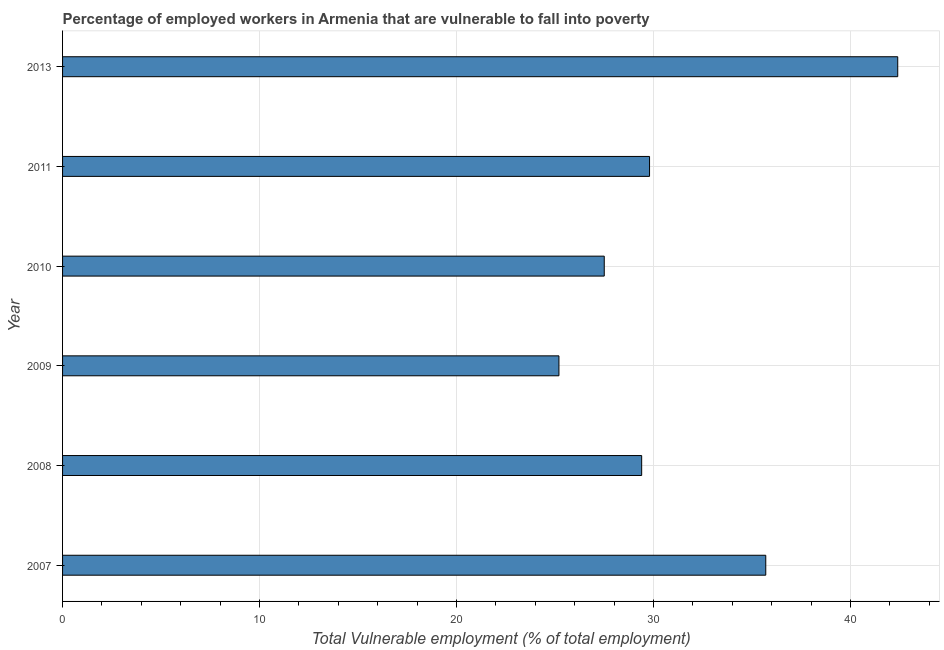What is the title of the graph?
Your answer should be compact. Percentage of employed workers in Armenia that are vulnerable to fall into poverty. What is the label or title of the X-axis?
Offer a very short reply. Total Vulnerable employment (% of total employment). What is the label or title of the Y-axis?
Ensure brevity in your answer.  Year. What is the total vulnerable employment in 2013?
Your answer should be compact. 42.4. Across all years, what is the maximum total vulnerable employment?
Your answer should be compact. 42.4. Across all years, what is the minimum total vulnerable employment?
Make the answer very short. 25.2. In which year was the total vulnerable employment maximum?
Offer a very short reply. 2013. What is the sum of the total vulnerable employment?
Offer a very short reply. 190. What is the difference between the total vulnerable employment in 2007 and 2008?
Your response must be concise. 6.3. What is the average total vulnerable employment per year?
Make the answer very short. 31.67. What is the median total vulnerable employment?
Offer a terse response. 29.6. Do a majority of the years between 2008 and 2010 (inclusive) have total vulnerable employment greater than 22 %?
Your answer should be compact. Yes. What is the ratio of the total vulnerable employment in 2007 to that in 2009?
Offer a terse response. 1.42. Is the total vulnerable employment in 2007 less than that in 2008?
Provide a succinct answer. No. Is the sum of the total vulnerable employment in 2010 and 2011 greater than the maximum total vulnerable employment across all years?
Offer a very short reply. Yes. In how many years, is the total vulnerable employment greater than the average total vulnerable employment taken over all years?
Provide a short and direct response. 2. How many bars are there?
Your answer should be very brief. 6. Are the values on the major ticks of X-axis written in scientific E-notation?
Give a very brief answer. No. What is the Total Vulnerable employment (% of total employment) in 2007?
Give a very brief answer. 35.7. What is the Total Vulnerable employment (% of total employment) in 2008?
Offer a terse response. 29.4. What is the Total Vulnerable employment (% of total employment) of 2009?
Offer a terse response. 25.2. What is the Total Vulnerable employment (% of total employment) in 2011?
Make the answer very short. 29.8. What is the Total Vulnerable employment (% of total employment) in 2013?
Give a very brief answer. 42.4. What is the difference between the Total Vulnerable employment (% of total employment) in 2007 and 2009?
Make the answer very short. 10.5. What is the difference between the Total Vulnerable employment (% of total employment) in 2007 and 2010?
Your response must be concise. 8.2. What is the difference between the Total Vulnerable employment (% of total employment) in 2007 and 2011?
Your answer should be very brief. 5.9. What is the difference between the Total Vulnerable employment (% of total employment) in 2007 and 2013?
Keep it short and to the point. -6.7. What is the difference between the Total Vulnerable employment (% of total employment) in 2008 and 2009?
Make the answer very short. 4.2. What is the difference between the Total Vulnerable employment (% of total employment) in 2008 and 2010?
Make the answer very short. 1.9. What is the difference between the Total Vulnerable employment (% of total employment) in 2008 and 2011?
Your response must be concise. -0.4. What is the difference between the Total Vulnerable employment (% of total employment) in 2009 and 2013?
Ensure brevity in your answer.  -17.2. What is the difference between the Total Vulnerable employment (% of total employment) in 2010 and 2013?
Ensure brevity in your answer.  -14.9. What is the difference between the Total Vulnerable employment (% of total employment) in 2011 and 2013?
Provide a succinct answer. -12.6. What is the ratio of the Total Vulnerable employment (% of total employment) in 2007 to that in 2008?
Provide a short and direct response. 1.21. What is the ratio of the Total Vulnerable employment (% of total employment) in 2007 to that in 2009?
Make the answer very short. 1.42. What is the ratio of the Total Vulnerable employment (% of total employment) in 2007 to that in 2010?
Provide a short and direct response. 1.3. What is the ratio of the Total Vulnerable employment (% of total employment) in 2007 to that in 2011?
Provide a short and direct response. 1.2. What is the ratio of the Total Vulnerable employment (% of total employment) in 2007 to that in 2013?
Offer a very short reply. 0.84. What is the ratio of the Total Vulnerable employment (% of total employment) in 2008 to that in 2009?
Keep it short and to the point. 1.17. What is the ratio of the Total Vulnerable employment (% of total employment) in 2008 to that in 2010?
Your response must be concise. 1.07. What is the ratio of the Total Vulnerable employment (% of total employment) in 2008 to that in 2013?
Make the answer very short. 0.69. What is the ratio of the Total Vulnerable employment (% of total employment) in 2009 to that in 2010?
Give a very brief answer. 0.92. What is the ratio of the Total Vulnerable employment (% of total employment) in 2009 to that in 2011?
Ensure brevity in your answer.  0.85. What is the ratio of the Total Vulnerable employment (% of total employment) in 2009 to that in 2013?
Provide a short and direct response. 0.59. What is the ratio of the Total Vulnerable employment (% of total employment) in 2010 to that in 2011?
Offer a terse response. 0.92. What is the ratio of the Total Vulnerable employment (% of total employment) in 2010 to that in 2013?
Your answer should be compact. 0.65. What is the ratio of the Total Vulnerable employment (% of total employment) in 2011 to that in 2013?
Offer a terse response. 0.7. 